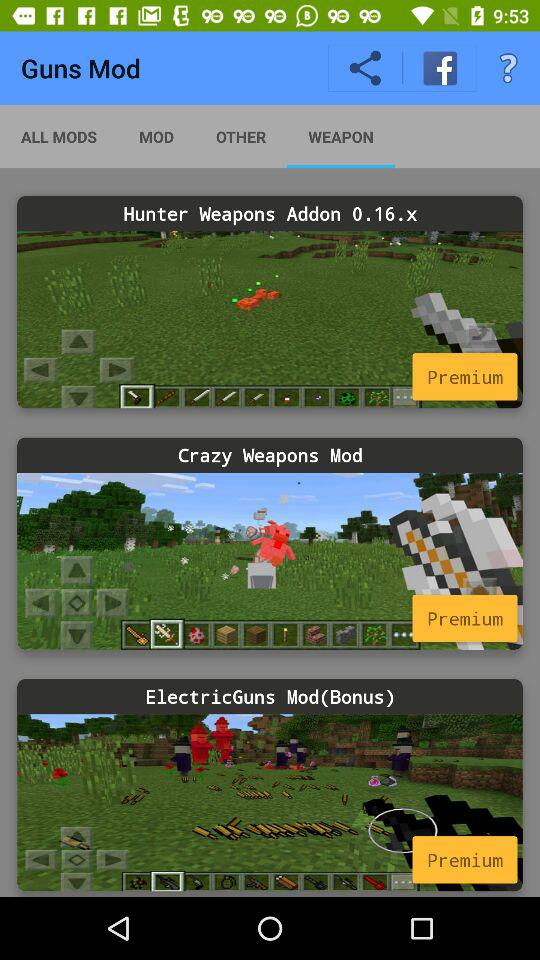Which tab is open? The open tab is "WEAPON". 